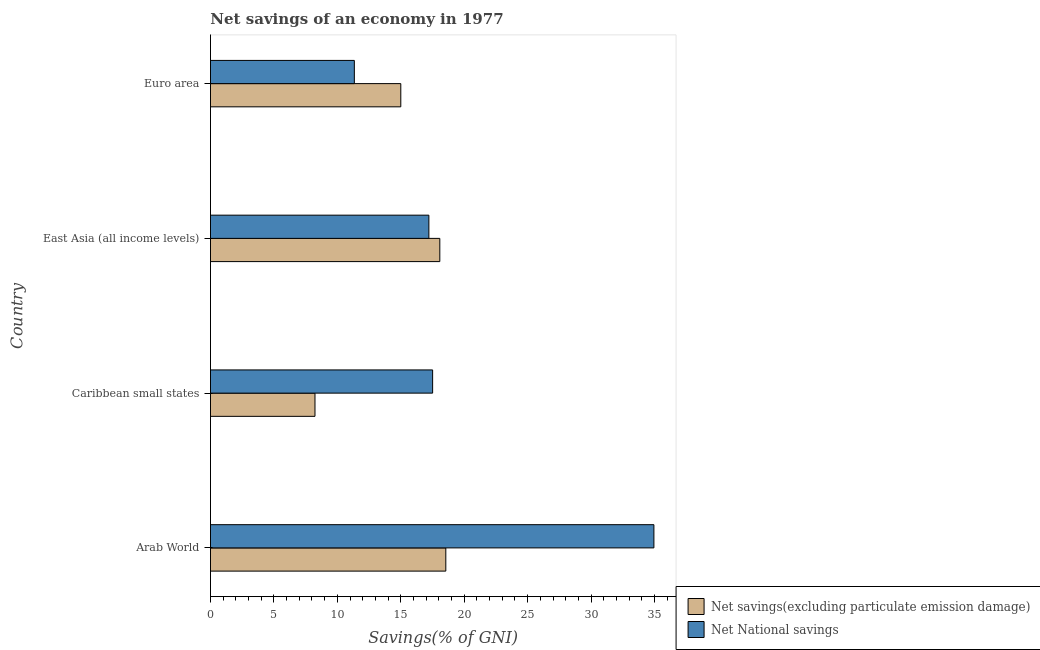How many different coloured bars are there?
Provide a succinct answer. 2. Are the number of bars per tick equal to the number of legend labels?
Your answer should be compact. Yes. Are the number of bars on each tick of the Y-axis equal?
Offer a very short reply. Yes. How many bars are there on the 2nd tick from the top?
Your answer should be compact. 2. How many bars are there on the 3rd tick from the bottom?
Give a very brief answer. 2. What is the label of the 3rd group of bars from the top?
Offer a terse response. Caribbean small states. What is the net national savings in East Asia (all income levels)?
Your answer should be very brief. 17.21. Across all countries, what is the maximum net savings(excluding particulate emission damage)?
Your answer should be compact. 18.55. Across all countries, what is the minimum net national savings?
Keep it short and to the point. 11.34. In which country was the net national savings maximum?
Provide a succinct answer. Arab World. In which country was the net national savings minimum?
Make the answer very short. Euro area. What is the total net savings(excluding particulate emission damage) in the graph?
Your answer should be very brief. 59.86. What is the difference between the net national savings in Caribbean small states and that in East Asia (all income levels)?
Your answer should be very brief. 0.3. What is the difference between the net savings(excluding particulate emission damage) in Euro area and the net national savings in Caribbean small states?
Your response must be concise. -2.51. What is the average net national savings per country?
Offer a terse response. 20.25. What is the difference between the net savings(excluding particulate emission damage) and net national savings in East Asia (all income levels)?
Keep it short and to the point. 0.86. What is the ratio of the net savings(excluding particulate emission damage) in Arab World to that in Euro area?
Offer a terse response. 1.24. Is the net national savings in Arab World less than that in East Asia (all income levels)?
Provide a short and direct response. No. Is the difference between the net national savings in Caribbean small states and East Asia (all income levels) greater than the difference between the net savings(excluding particulate emission damage) in Caribbean small states and East Asia (all income levels)?
Your answer should be very brief. Yes. What is the difference between the highest and the second highest net national savings?
Make the answer very short. 17.44. What is the difference between the highest and the lowest net savings(excluding particulate emission damage)?
Keep it short and to the point. 10.31. What does the 2nd bar from the top in Euro area represents?
Offer a terse response. Net savings(excluding particulate emission damage). What does the 2nd bar from the bottom in East Asia (all income levels) represents?
Your answer should be compact. Net National savings. How many bars are there?
Keep it short and to the point. 8. What is the difference between two consecutive major ticks on the X-axis?
Provide a short and direct response. 5. Are the values on the major ticks of X-axis written in scientific E-notation?
Your response must be concise. No. What is the title of the graph?
Provide a succinct answer. Net savings of an economy in 1977. Does "Number of arrivals" appear as one of the legend labels in the graph?
Provide a succinct answer. No. What is the label or title of the X-axis?
Make the answer very short. Savings(% of GNI). What is the Savings(% of GNI) in Net savings(excluding particulate emission damage) in Arab World?
Make the answer very short. 18.55. What is the Savings(% of GNI) in Net National savings in Arab World?
Make the answer very short. 34.95. What is the Savings(% of GNI) in Net savings(excluding particulate emission damage) in Caribbean small states?
Your answer should be compact. 8.24. What is the Savings(% of GNI) in Net National savings in Caribbean small states?
Offer a terse response. 17.51. What is the Savings(% of GNI) of Net savings(excluding particulate emission damage) in East Asia (all income levels)?
Provide a short and direct response. 18.07. What is the Savings(% of GNI) in Net National savings in East Asia (all income levels)?
Offer a very short reply. 17.21. What is the Savings(% of GNI) in Net savings(excluding particulate emission damage) in Euro area?
Make the answer very short. 15. What is the Savings(% of GNI) of Net National savings in Euro area?
Your answer should be very brief. 11.34. Across all countries, what is the maximum Savings(% of GNI) in Net savings(excluding particulate emission damage)?
Your answer should be very brief. 18.55. Across all countries, what is the maximum Savings(% of GNI) in Net National savings?
Offer a terse response. 34.95. Across all countries, what is the minimum Savings(% of GNI) in Net savings(excluding particulate emission damage)?
Keep it short and to the point. 8.24. Across all countries, what is the minimum Savings(% of GNI) in Net National savings?
Offer a terse response. 11.34. What is the total Savings(% of GNI) of Net savings(excluding particulate emission damage) in the graph?
Your response must be concise. 59.86. What is the total Savings(% of GNI) of Net National savings in the graph?
Your answer should be compact. 81.01. What is the difference between the Savings(% of GNI) of Net savings(excluding particulate emission damage) in Arab World and that in Caribbean small states?
Your answer should be very brief. 10.31. What is the difference between the Savings(% of GNI) in Net National savings in Arab World and that in Caribbean small states?
Offer a very short reply. 17.44. What is the difference between the Savings(% of GNI) in Net savings(excluding particulate emission damage) in Arab World and that in East Asia (all income levels)?
Your answer should be very brief. 0.47. What is the difference between the Savings(% of GNI) in Net National savings in Arab World and that in East Asia (all income levels)?
Give a very brief answer. 17.74. What is the difference between the Savings(% of GNI) in Net savings(excluding particulate emission damage) in Arab World and that in Euro area?
Provide a short and direct response. 3.55. What is the difference between the Savings(% of GNI) in Net National savings in Arab World and that in Euro area?
Your response must be concise. 23.61. What is the difference between the Savings(% of GNI) of Net savings(excluding particulate emission damage) in Caribbean small states and that in East Asia (all income levels)?
Offer a terse response. -9.84. What is the difference between the Savings(% of GNI) in Net National savings in Caribbean small states and that in East Asia (all income levels)?
Make the answer very short. 0.3. What is the difference between the Savings(% of GNI) of Net savings(excluding particulate emission damage) in Caribbean small states and that in Euro area?
Keep it short and to the point. -6.76. What is the difference between the Savings(% of GNI) in Net National savings in Caribbean small states and that in Euro area?
Offer a terse response. 6.17. What is the difference between the Savings(% of GNI) in Net savings(excluding particulate emission damage) in East Asia (all income levels) and that in Euro area?
Your response must be concise. 3.08. What is the difference between the Savings(% of GNI) in Net National savings in East Asia (all income levels) and that in Euro area?
Your response must be concise. 5.87. What is the difference between the Savings(% of GNI) in Net savings(excluding particulate emission damage) in Arab World and the Savings(% of GNI) in Net National savings in Caribbean small states?
Offer a very short reply. 1.04. What is the difference between the Savings(% of GNI) in Net savings(excluding particulate emission damage) in Arab World and the Savings(% of GNI) in Net National savings in East Asia (all income levels)?
Your response must be concise. 1.34. What is the difference between the Savings(% of GNI) in Net savings(excluding particulate emission damage) in Arab World and the Savings(% of GNI) in Net National savings in Euro area?
Make the answer very short. 7.21. What is the difference between the Savings(% of GNI) in Net savings(excluding particulate emission damage) in Caribbean small states and the Savings(% of GNI) in Net National savings in East Asia (all income levels)?
Your response must be concise. -8.98. What is the difference between the Savings(% of GNI) in Net savings(excluding particulate emission damage) in Caribbean small states and the Savings(% of GNI) in Net National savings in Euro area?
Offer a terse response. -3.1. What is the difference between the Savings(% of GNI) of Net savings(excluding particulate emission damage) in East Asia (all income levels) and the Savings(% of GNI) of Net National savings in Euro area?
Your answer should be very brief. 6.74. What is the average Savings(% of GNI) in Net savings(excluding particulate emission damage) per country?
Provide a short and direct response. 14.96. What is the average Savings(% of GNI) of Net National savings per country?
Offer a very short reply. 20.25. What is the difference between the Savings(% of GNI) of Net savings(excluding particulate emission damage) and Savings(% of GNI) of Net National savings in Arab World?
Your answer should be compact. -16.4. What is the difference between the Savings(% of GNI) in Net savings(excluding particulate emission damage) and Savings(% of GNI) in Net National savings in Caribbean small states?
Offer a terse response. -9.27. What is the difference between the Savings(% of GNI) of Net savings(excluding particulate emission damage) and Savings(% of GNI) of Net National savings in East Asia (all income levels)?
Offer a terse response. 0.86. What is the difference between the Savings(% of GNI) in Net savings(excluding particulate emission damage) and Savings(% of GNI) in Net National savings in Euro area?
Keep it short and to the point. 3.66. What is the ratio of the Savings(% of GNI) of Net savings(excluding particulate emission damage) in Arab World to that in Caribbean small states?
Make the answer very short. 2.25. What is the ratio of the Savings(% of GNI) of Net National savings in Arab World to that in Caribbean small states?
Keep it short and to the point. 2. What is the ratio of the Savings(% of GNI) of Net savings(excluding particulate emission damage) in Arab World to that in East Asia (all income levels)?
Offer a terse response. 1.03. What is the ratio of the Savings(% of GNI) of Net National savings in Arab World to that in East Asia (all income levels)?
Ensure brevity in your answer.  2.03. What is the ratio of the Savings(% of GNI) of Net savings(excluding particulate emission damage) in Arab World to that in Euro area?
Ensure brevity in your answer.  1.24. What is the ratio of the Savings(% of GNI) of Net National savings in Arab World to that in Euro area?
Ensure brevity in your answer.  3.08. What is the ratio of the Savings(% of GNI) in Net savings(excluding particulate emission damage) in Caribbean small states to that in East Asia (all income levels)?
Offer a terse response. 0.46. What is the ratio of the Savings(% of GNI) of Net National savings in Caribbean small states to that in East Asia (all income levels)?
Offer a very short reply. 1.02. What is the ratio of the Savings(% of GNI) in Net savings(excluding particulate emission damage) in Caribbean small states to that in Euro area?
Make the answer very short. 0.55. What is the ratio of the Savings(% of GNI) of Net National savings in Caribbean small states to that in Euro area?
Make the answer very short. 1.54. What is the ratio of the Savings(% of GNI) in Net savings(excluding particulate emission damage) in East Asia (all income levels) to that in Euro area?
Make the answer very short. 1.21. What is the ratio of the Savings(% of GNI) in Net National savings in East Asia (all income levels) to that in Euro area?
Provide a short and direct response. 1.52. What is the difference between the highest and the second highest Savings(% of GNI) in Net savings(excluding particulate emission damage)?
Offer a terse response. 0.47. What is the difference between the highest and the second highest Savings(% of GNI) in Net National savings?
Your response must be concise. 17.44. What is the difference between the highest and the lowest Savings(% of GNI) in Net savings(excluding particulate emission damage)?
Make the answer very short. 10.31. What is the difference between the highest and the lowest Savings(% of GNI) in Net National savings?
Ensure brevity in your answer.  23.61. 